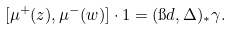Convert formula to latex. <formula><loc_0><loc_0><loc_500><loc_500>[ \mu ^ { + } ( z ) , \mu ^ { - } ( w ) ] \cdot 1 = ( \i d , \Delta ) _ { \ast } \gamma .</formula> 